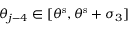<formula> <loc_0><loc_0><loc_500><loc_500>\theta _ { j - 4 } \in [ \theta ^ { s } , \theta ^ { s } + \sigma _ { 3 } ]</formula> 